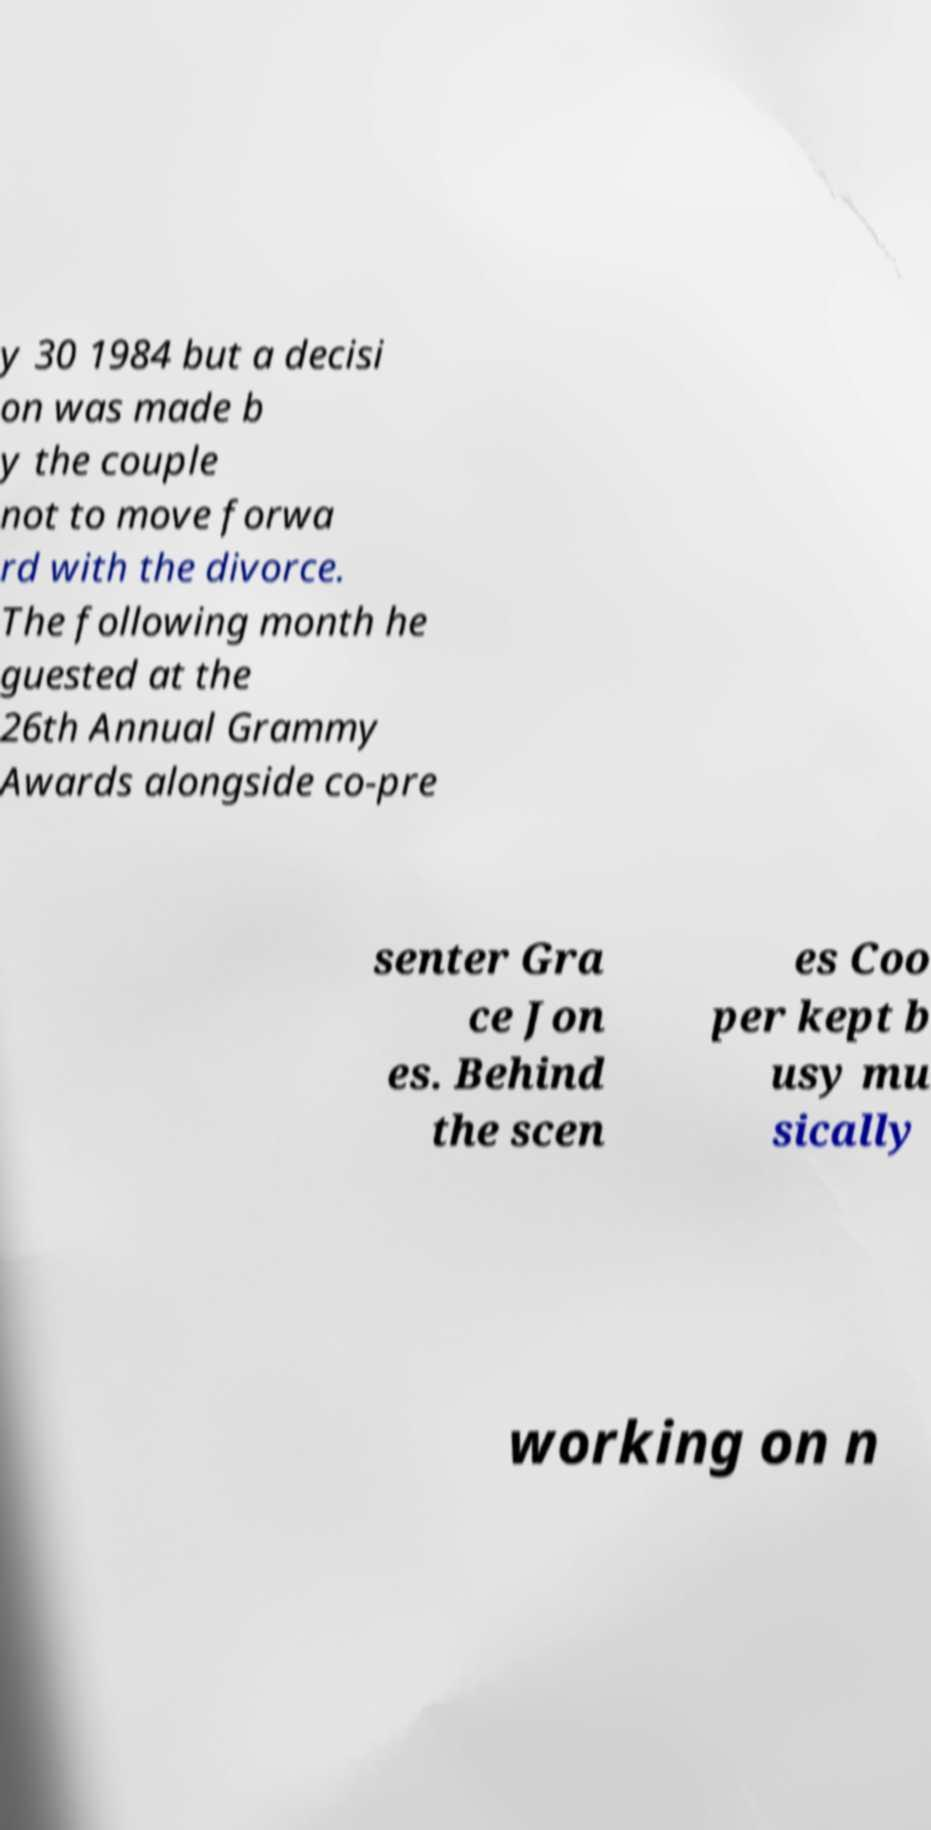I need the written content from this picture converted into text. Can you do that? y 30 1984 but a decisi on was made b y the couple not to move forwa rd with the divorce. The following month he guested at the 26th Annual Grammy Awards alongside co-pre senter Gra ce Jon es. Behind the scen es Coo per kept b usy mu sically working on n 